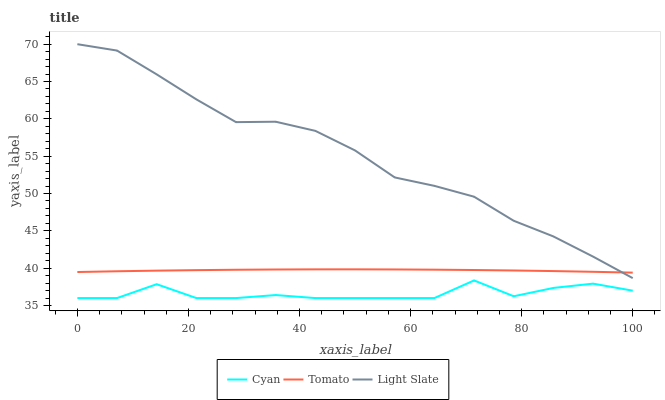Does Light Slate have the minimum area under the curve?
Answer yes or no. No. Does Cyan have the maximum area under the curve?
Answer yes or no. No. Is Light Slate the smoothest?
Answer yes or no. No. Is Light Slate the roughest?
Answer yes or no. No. Does Light Slate have the lowest value?
Answer yes or no. No. Does Cyan have the highest value?
Answer yes or no. No. Is Cyan less than Light Slate?
Answer yes or no. Yes. Is Tomato greater than Cyan?
Answer yes or no. Yes. Does Cyan intersect Light Slate?
Answer yes or no. No. 